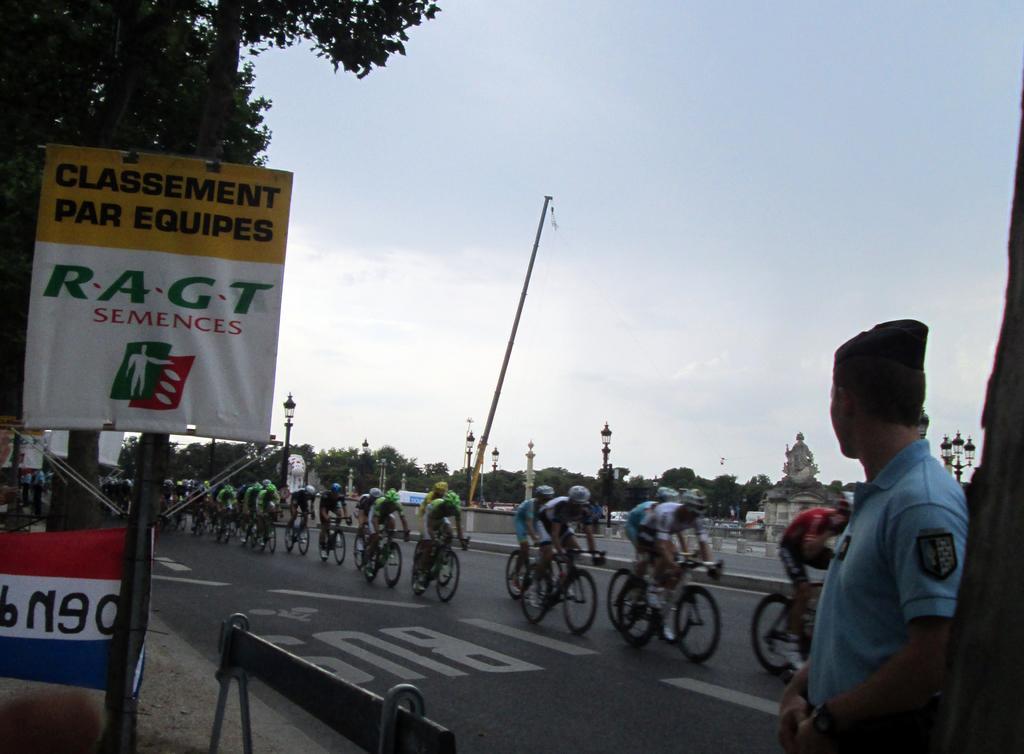Could you give a brief overview of what you see in this image? In this picture we can see group of people riding bicycle on road and here person is watching them and in background we can see trees, pole, sky, banner. 